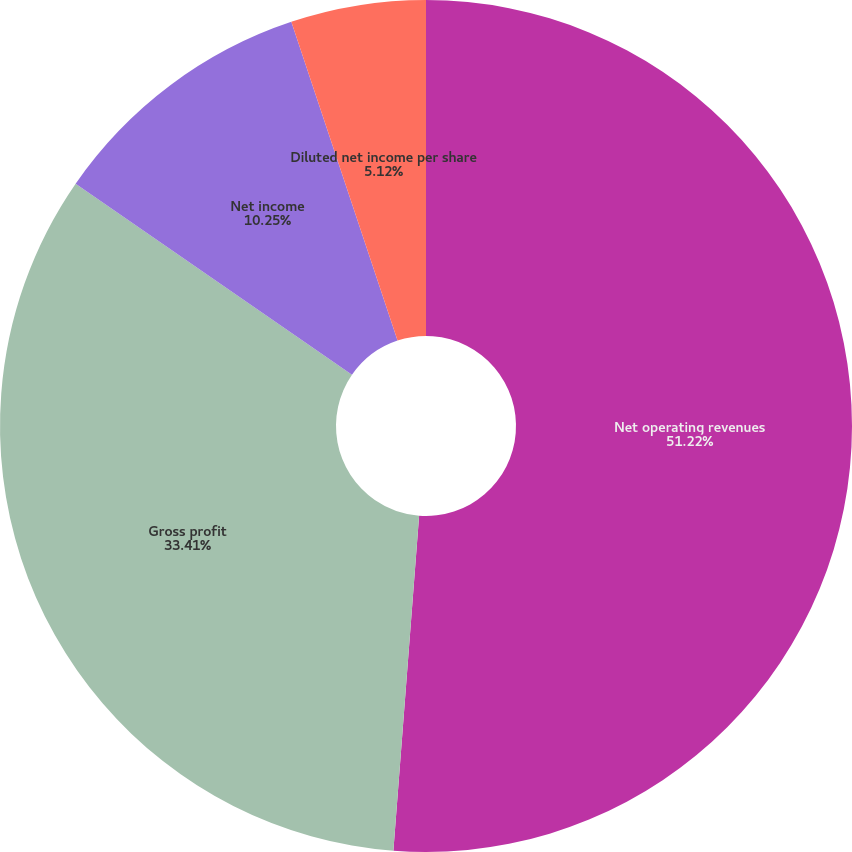Convert chart. <chart><loc_0><loc_0><loc_500><loc_500><pie_chart><fcel>Net operating revenues<fcel>Gross profit<fcel>Net income<fcel>Basic net income per share<fcel>Diluted net income per share<nl><fcel>51.22%<fcel>33.41%<fcel>10.25%<fcel>0.0%<fcel>5.12%<nl></chart> 